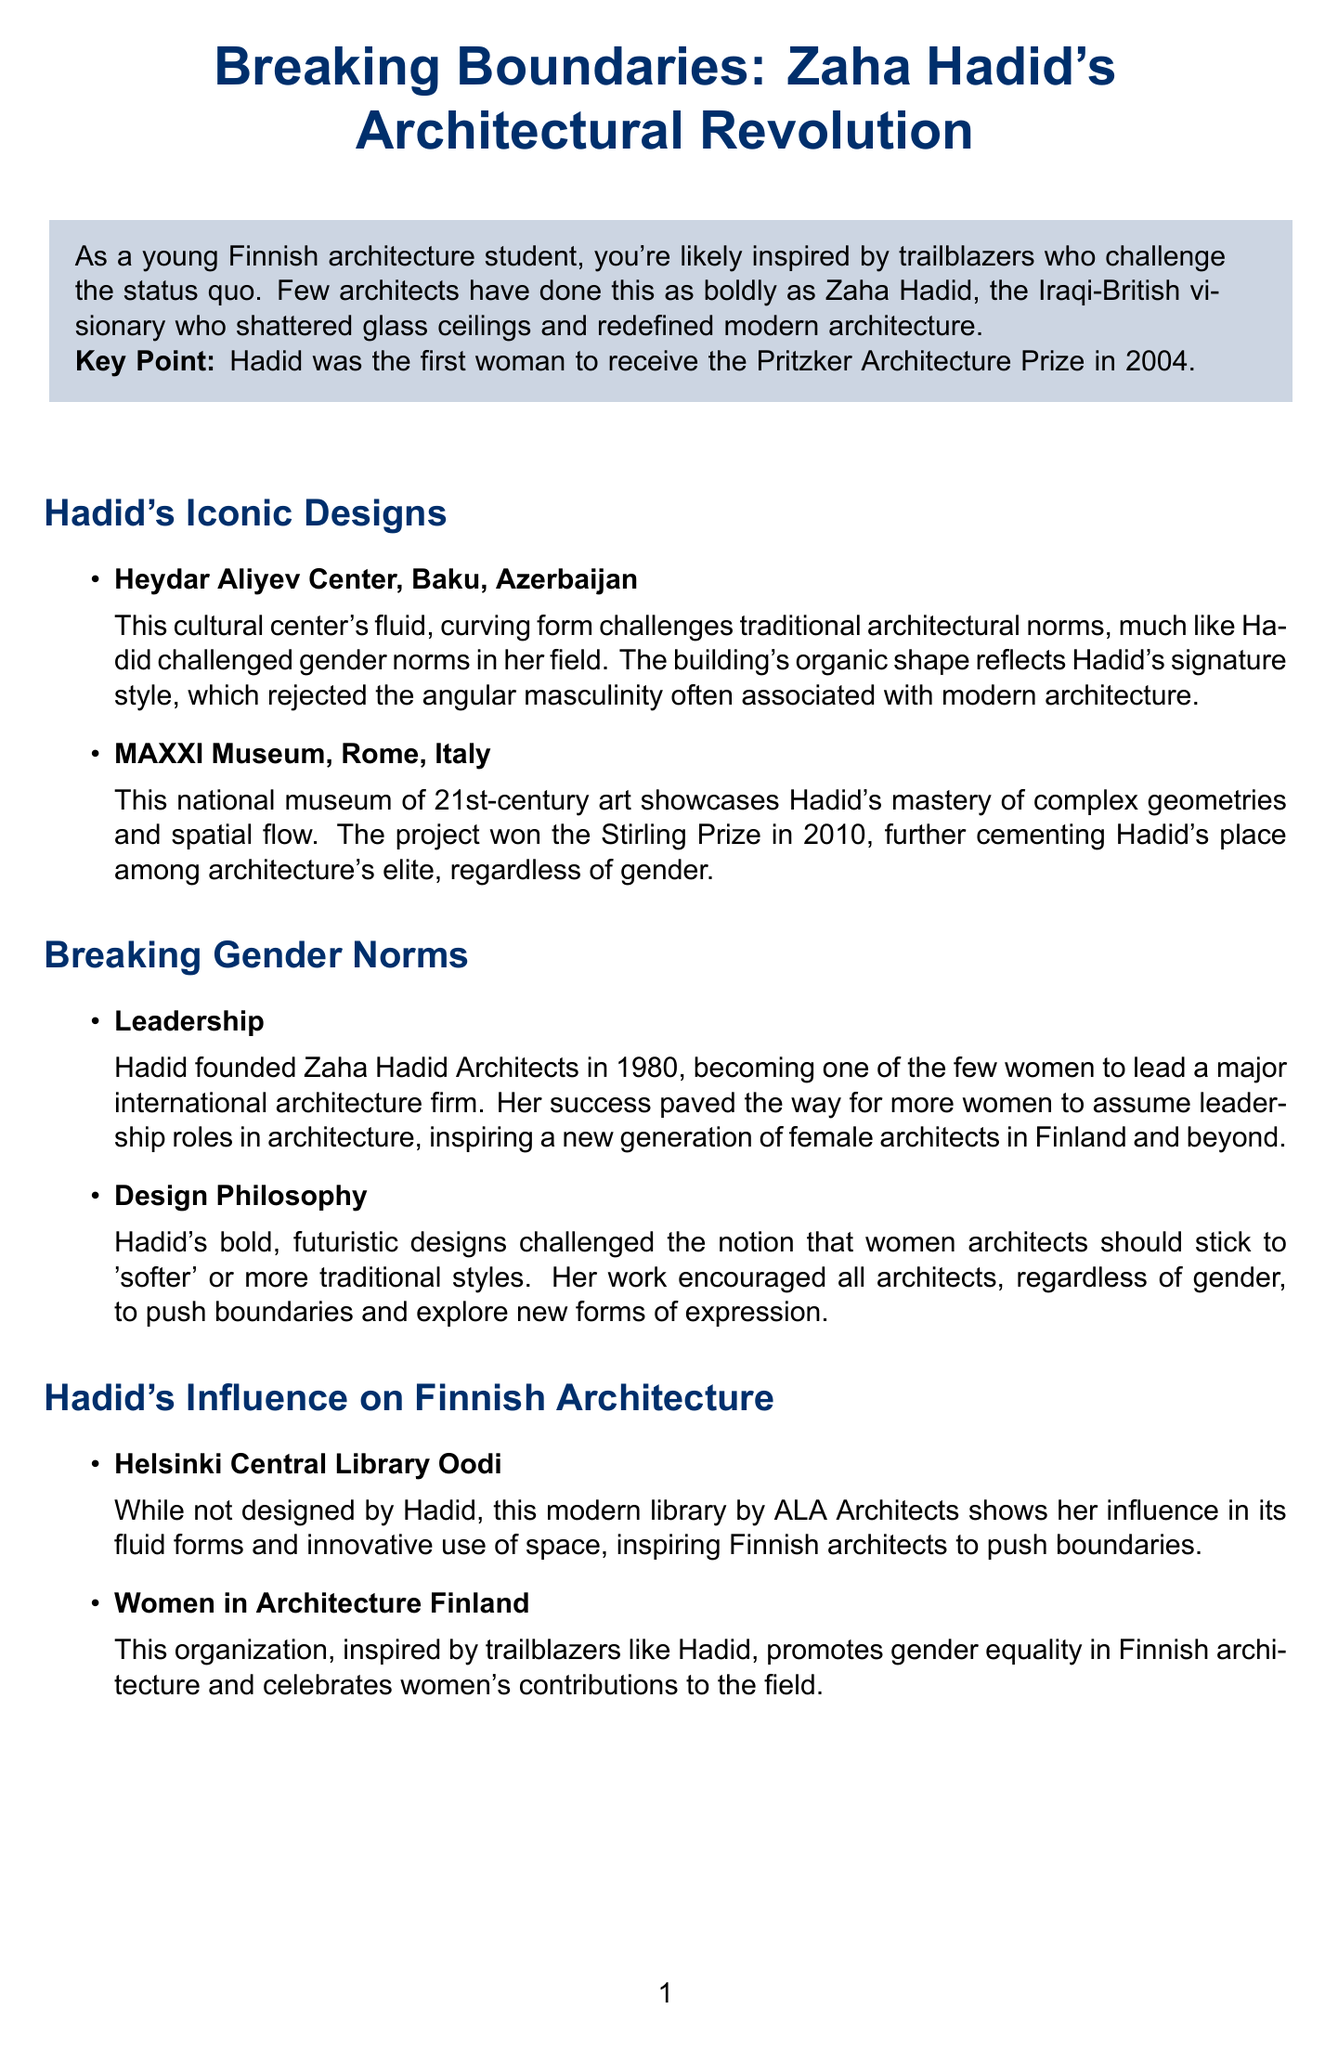What is Hadid's nationality? Hadid was an Iraqi-British visionary, which states her national identity.
Answer: Iraqi-British In what year did Hadid win the Pritzker Architecture Prize? The document states that Hadid was the first woman to receive the Pritzker Architecture Prize in 2004.
Answer: 2004 Which project won the Stirling Prize in 2010? The document lists MAXXI Museum as the project that won the Stirling Prize in 2010.
Answer: MAXXI Museum What architectural firm did Hadid found? The document mentions Zaha Hadid Architects as the firm founded by Hadid.
Answer: Zaha Hadid Architects How did Hadid's design philosophy challenge gender norms? The document states that her bold, futuristic designs rejected 'softer' traditional styles associated with women architects.
Answer: Rejecting 'softer' traditional styles What influence did Hadid have on Finnish architecture? The document outlines that her influence can be seen in the Helsinki Central Library Oodi.
Answer: Helsinki Central Library Oodi What organization promotes gender equality in Finnish architecture? The document identifies Women in Architecture Finland as the organization promoting this cause.
Answer: Women in Architecture Finland What type of resources are provided at the end of the document? The document lists additional resources like books, documentaries, and exhibitions relevant to Zaha Hadid.
Answer: Books, documentaries, exhibitions Which architectural style is mostly associated with Hadid's projects? The document describes Hadid's projects as having fluid, curving forms indicative of her architectural style.
Answer: Fluid, curving forms 